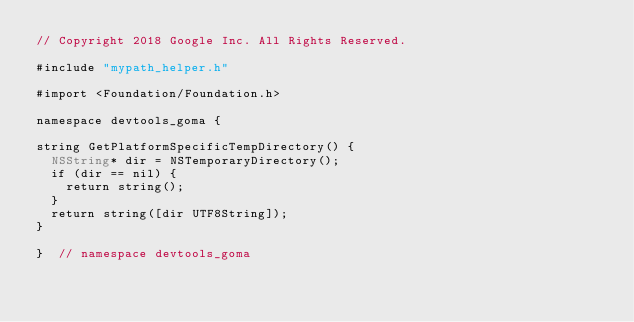<code> <loc_0><loc_0><loc_500><loc_500><_ObjectiveC_>// Copyright 2018 Google Inc. All Rights Reserved.

#include "mypath_helper.h"

#import <Foundation/Foundation.h>

namespace devtools_goma {

string GetPlatformSpecificTempDirectory() {
  NSString* dir = NSTemporaryDirectory();
  if (dir == nil) {
    return string();
  }
  return string([dir UTF8String]);
}

}  // namespace devtools_goma
</code> 